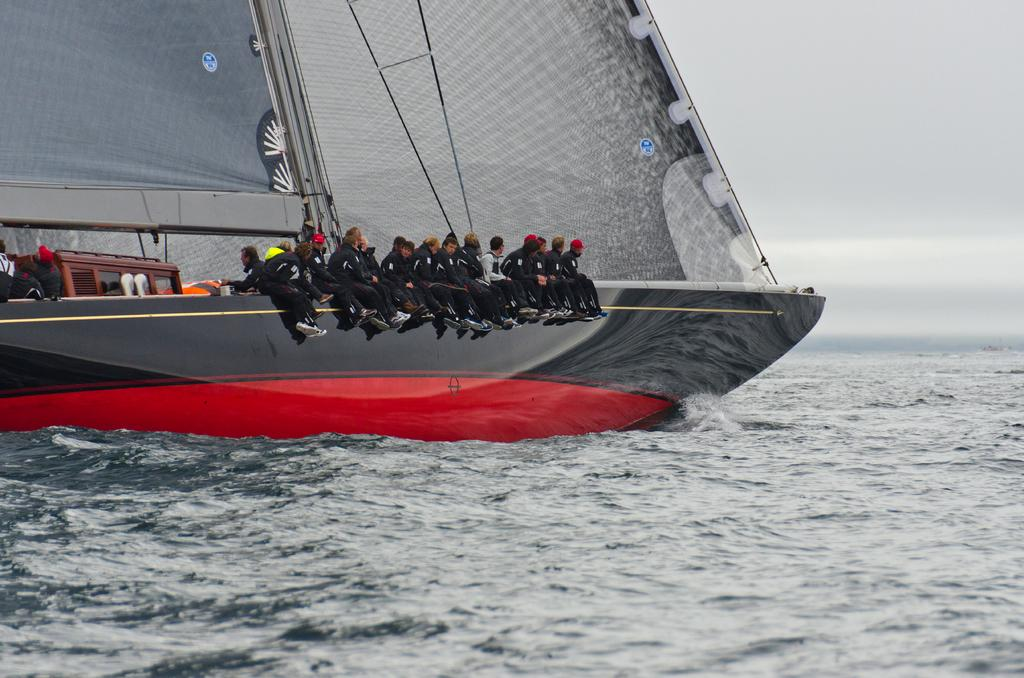What is the main subject of the image? The main subject of the image is a boat. What are the people in the boat doing? The people are sailing in the boat. What can be seen in the background of the image? There is water and the sky visible in the image. How many cows are swimming alongside the boat in the image? There are no cows present in the image; it features a boat with people sailing on water. What type of vegetable is growing on the boat in the image? There are no vegetables growing on the boat in the image; it only shows a boat with people sailing on water. 